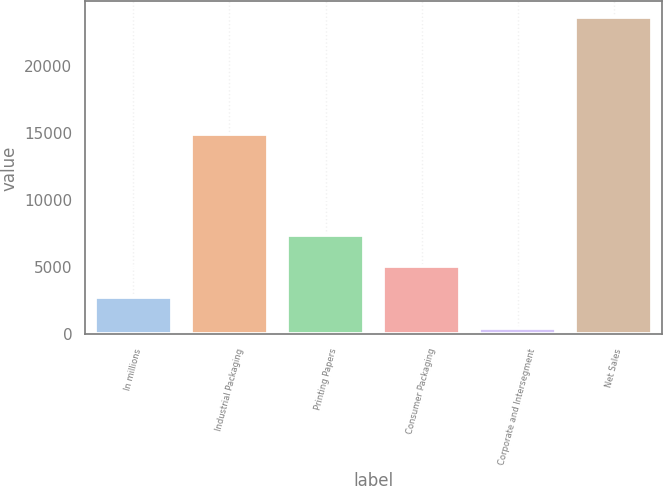Convert chart. <chart><loc_0><loc_0><loc_500><loc_500><bar_chart><fcel>In millions<fcel>Industrial Packaging<fcel>Printing Papers<fcel>Consumer Packaging<fcel>Corporate and Intersegment<fcel>Net Sales<nl><fcel>2766.7<fcel>14944<fcel>7400.1<fcel>5083.4<fcel>450<fcel>23617<nl></chart> 